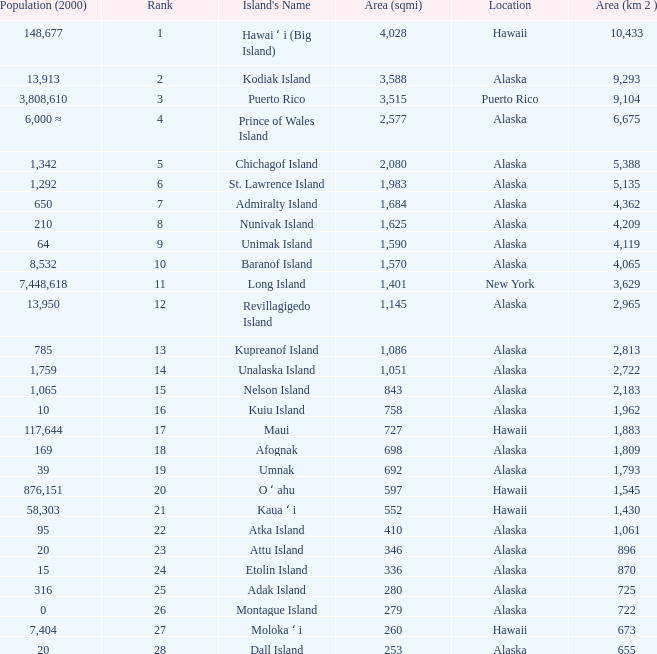What is the largest rank with 2,080 area? 5.0. 